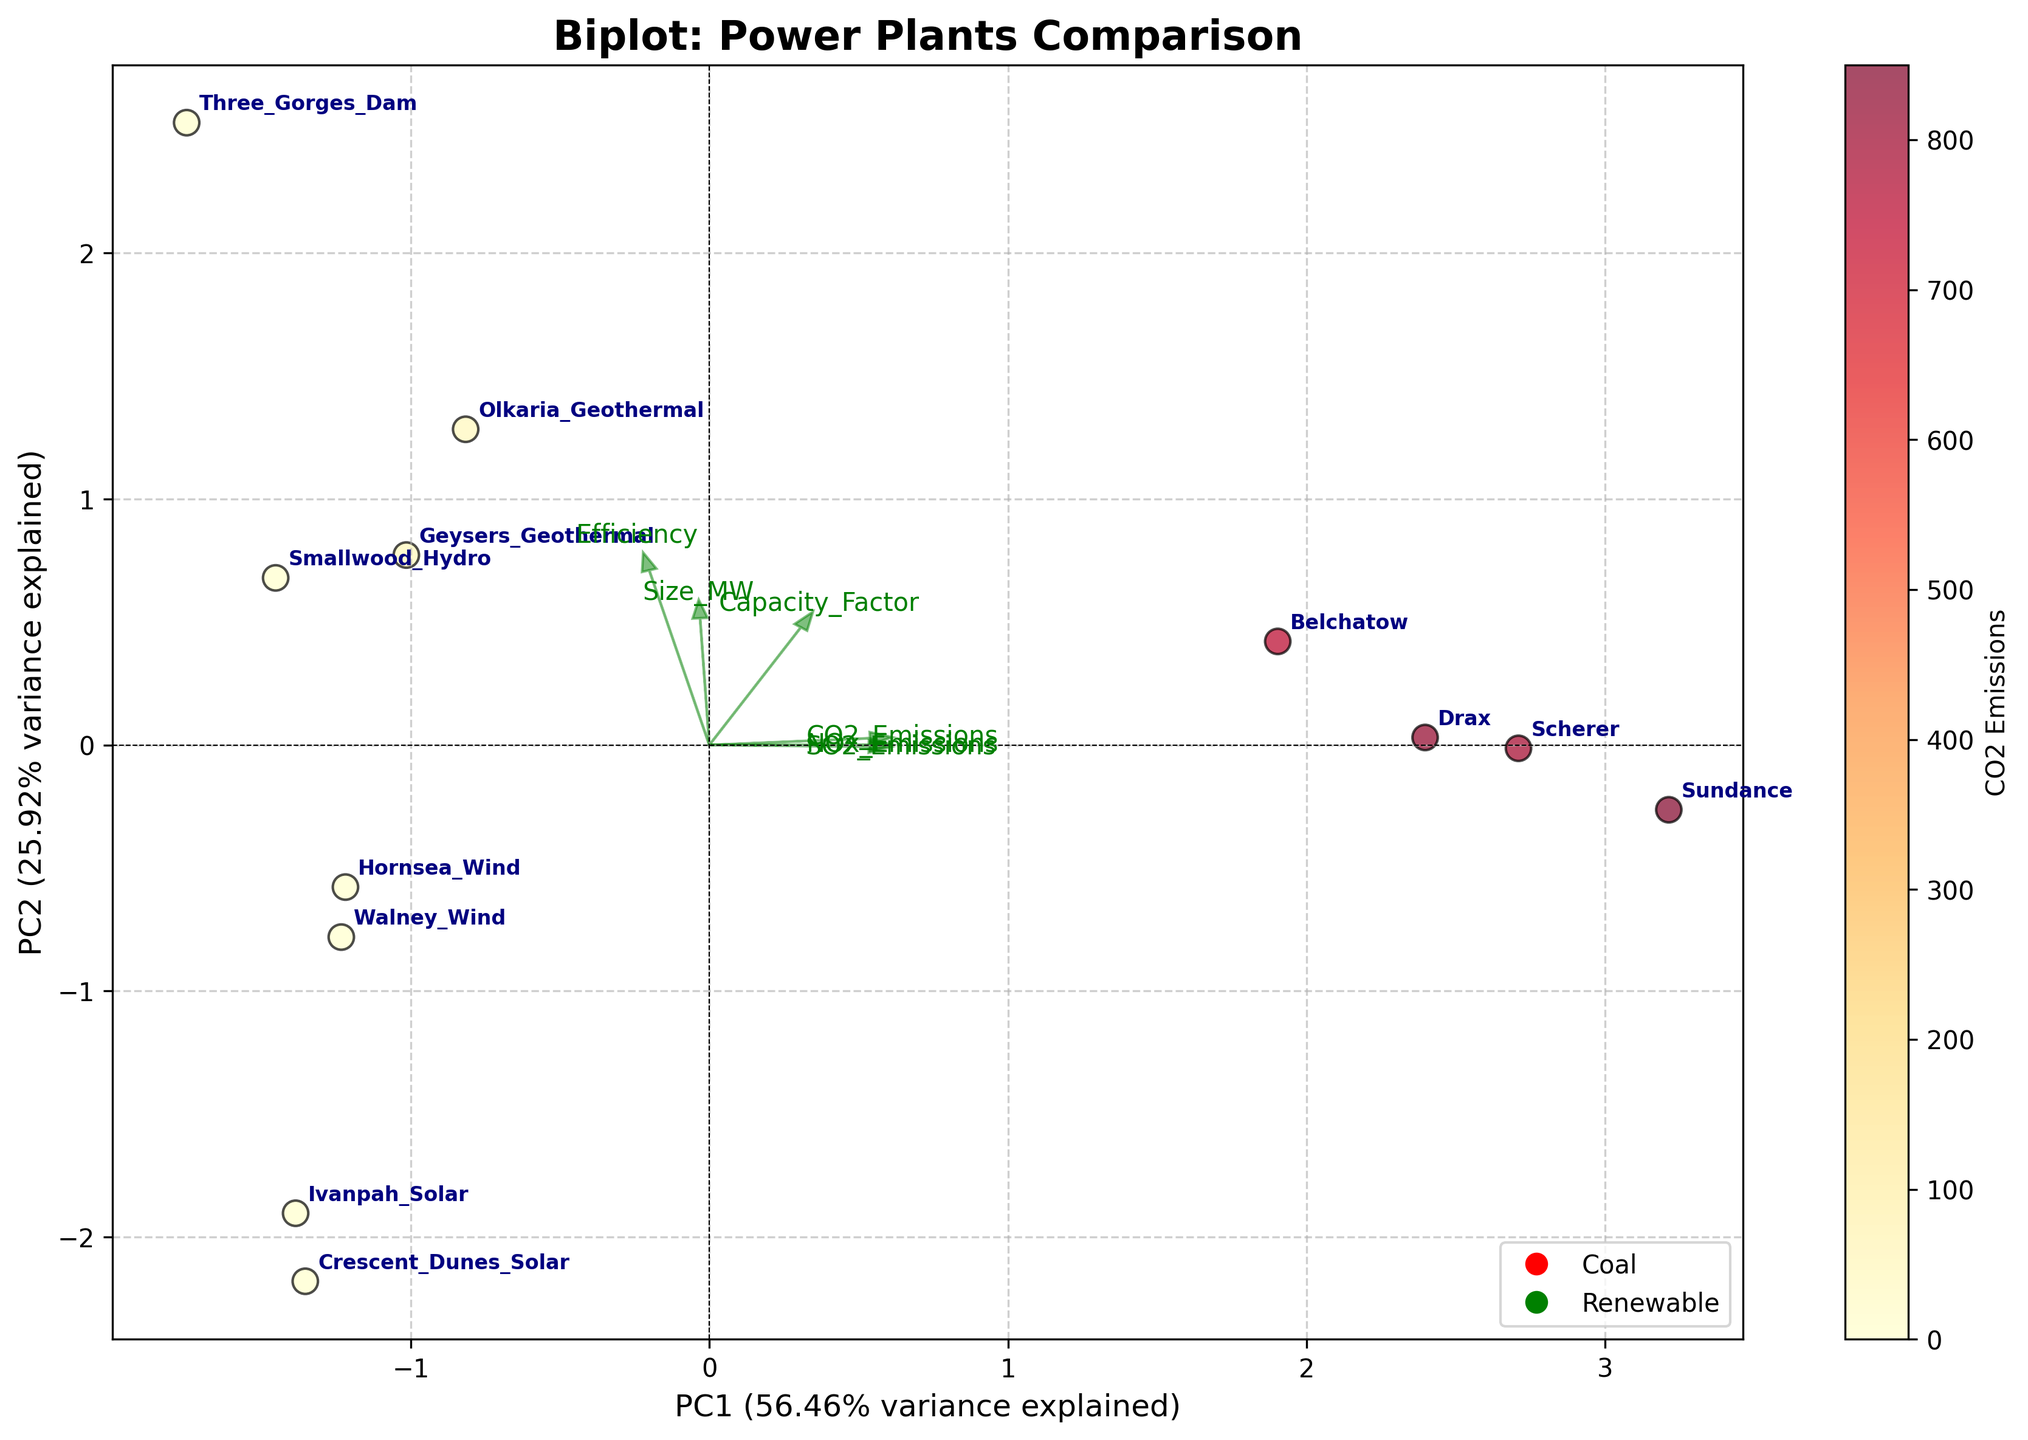What is the title of the biplot? The title of the figure is written at the top in bold.
Answer: Biplot: Power Plants Comparison How many total power plants are compared in the plot? Count the number of data points labeled with plant names.
Answer: 12 Which feature contributes the most to PC1 component? The longest vector along the x-axis direction represents the highest contribution to PC1.
Answer: Size_MW Which power plant has the highest efficiency? Look for the plant label closest to the tip of the vector labeled "Efficiency."
Answer: Three Gorges Dam What feature is represented by the shortest vector? How can you tell? The shortest vector has the least length among the plotted feature vectors.
Answer: SO2_Emissions Which coal plant has the highest CO2 emissions? Find the labeled coal plants and look for the one with the largest color intensity according to the colorbar.
Answer: Sundance How does the CO2 emissions of Hornsea Wind compare to Drax? Compare the color intensity of the points labeled "Hornsea Wind" and "Drax" according to the colorbar.
Answer: Hornsea Wind has lower CO2 emissions than Drax What percentage of variance is explained by the PC2 component? Read the percentage mentioned along the y-axis label.
Answer: 34.00% Which renewable plant has the highest capacity factor? Look for the plant closest to the vector labeled "Capacity_Factor."
Answer: Olkaria Geothermal Is size (Size_MW) typically larger for coal or renewable plants in this plot? Compare positions along the "Size_MW" vector direction of coal and renewable plant labels.
Answer: Coal plants are typically larger 